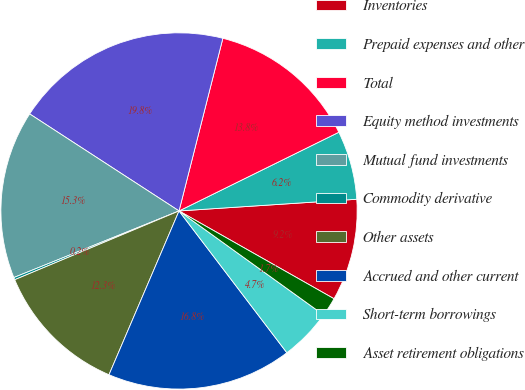Convert chart. <chart><loc_0><loc_0><loc_500><loc_500><pie_chart><fcel>Inventories<fcel>Prepaid expenses and other<fcel>Total<fcel>Equity method investments<fcel>Mutual fund investments<fcel>Commodity derivative<fcel>Other assets<fcel>Accrued and other current<fcel>Short-term borrowings<fcel>Asset retirement obligations<nl><fcel>9.25%<fcel>6.24%<fcel>13.76%<fcel>19.79%<fcel>15.27%<fcel>0.21%<fcel>12.26%<fcel>16.78%<fcel>4.73%<fcel>1.72%<nl></chart> 